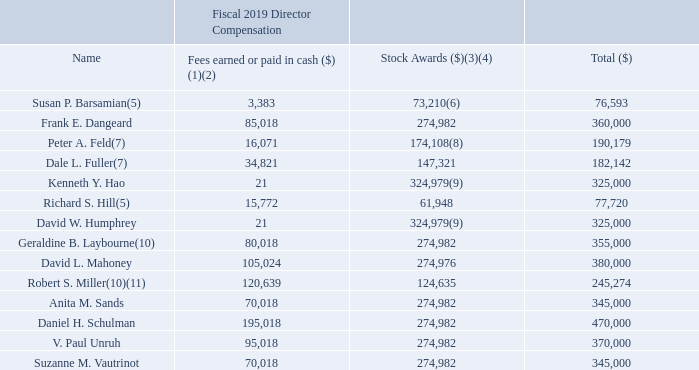The following table provides information for fiscal year 2019 compensation for all of our current and former non-employee directors:
1) Non-employee directors receive an annual retainer fee of $50,000 plus an additional annual fee of $15,000 (Compensation Committee and Nominating and Governance Committee) or $20,000 (Audit Committee) for membership on each committee. The chair of each committee receives an additional annual fee of $15,000 (Nominating and Governance Committee) or $25,000 (Audit Committee and Compensation Committee). The Lead Independent Director/Independent Chairman receives an annual fee of $100,000 (reduced to $75,000 for 2020).
(2) Includes payments for fractional share(s) from stock awards granted to each non-employee director.
(3) Amounts shown in this column reflect the aggregate full grant date fair value calculated in accordance with Financial Accounting Standards Board (‘‘FASB’’) Accounting Standards Codification (‘‘ASC’’) Topic 718 for awards granted during FY19.
(4) Each non-employee director, other than Ms. Barsamian and Messrs. Feld, Fuller, Hill and Miller, was granted 12,320 RSUs on May 17, 2018, with a per-share fair value of $22.32 and an aggregate grant date fair value of $274,982.40. Each such director’s fees were paid in cash as reported in the ‘‘Fees Earned or Paid in Cash’’ column in the table above. No non-employee director had any outstanding stock awards as of March 29, 2019.
(5) Ms. Barsamian and Mr. Hill were appointed to our Board on January 7, 2019 and received a pro-rated portion of non-employee director fees from the date of such director’s appointment on January 7, 2019 through the end of FY19. Ms. Barsamian and Mr. Hill were each granted 2,717 RSUs on February 5, 2019, with a per-share fair value of $22.80 and an aggregate grant date fair value of $61,947.60. The balance of each such director’s fees was paid in cash as reported in the ‘‘Fees Earned or Paid in Cash’’ column in the table above.
(6) In lieu of cash, Ms. Barsamian elected to receive 100% of the pro-rated portion of her annual retainer fee of $50,000 in the form of our common stock. Accordingly, pursuant to the terms of the 2000 Director Equity Incentive Plan, Ms. Barsamian was granted 494 shares at a per share fair value of $22.80 and an aggregate grant date fair value of $11,263. The balance of Ms. Barsamian’s fee was paid in cash as reported in the ‘‘Fees Earned or Paid in Cash’’ column in the table above.
(7) Messrs. Feld and Fuller were appointed to our Board on September 16, 2018 and each received pro-rated portions of such director’s non-employee director fees from the date of his appointment on September 16, 2018 through the end of FY19. Messrs. Feld and Fuller were granted 6,764 RSUs on December 7, 2018, with a per-share fair value of $21.78 and an aggregate grant date fair value of $147,320. The balance of each such director’s fees was paid in cash as reported in the ‘‘Fees Earned or Paid in Cash’’ column in the table above.
(8) In lieu of cash, Mr. Feld elected to receive 100% of the pro-rated portion of his annual retainer fee of $50,000 in the form of our common stock. Accordingly, pursuant to the terms of the 2000 Director Equity Incentive Plan, Mr. Feld was granted 1,229 shares at a per share fair value of $21.78 and an aggregate grant date fair value of $26,767. The balance of Mr. Feld’s fee was paid in cash as reported in the ‘‘Fees Earned or Paid in Cash’’ column in the table above.
(9) In lieu of cash, Messrs. Hao and Humphrey each received 100% of his respective annual retainer fee of $50,000 in the form of our common stock. Accordingly, pursuant to the terms of the 2000 Director Equity Incentive Plan, each was granted 2,240 shares at a per share fair value of $22.32 and an aggregate grant date fair value of $49,997. The balance of each such director’s fee was paid in cash as reported in the ‘‘Fees Earned or Paid in Cash’’ column in the table above.
(10) Ms. Laybourne and Mr. Miller served on the Board through December 3, 2018, the date of the Company’s 2019 Annual Meeting of Stockholders.
(11) Mr. Miller’s non-employee director fees were prorated through December 3, 2018, the date of the Company’s 2019 Annual Meeting of Stockholders. Mr. Miller was granted 5,584 RSUs on May 17, 2018, with a per-share fair value of $22.32 and an aggregate grant date fair value of $124,635. The balance in director’s fees was paid in cash as reported in the ‘‘Fees Earned or Paid in Cash’’ column in the table above.
What does the table show? Information for fiscal year 2019 compensation for all of our current and former non-employee directors. What annual fee does The Lead Independent Director/Independent Chairman receive? $100,000 (reduced to $75,000 for 2020). Of the non-employee directors, who were not granted 12,320 RSUs on May 17, 2018? Ms. barsamian and messrs. feld, fuller, hill and miller. How much more in Director compensation did Frank E. Dangeard have over Susan P. Barsamian? 360,000-76,593
Answer: 283407. Who are compensated greater than $400,000 for total director compensation? For each row, Select name in col2 if the value in col5 is greater than 400,000
Answer: daniel h. schulman. How much more in Director compensation did Peter A. Feld have over Dale L. Fuller? 190,179-182,142
Answer: 8037. 